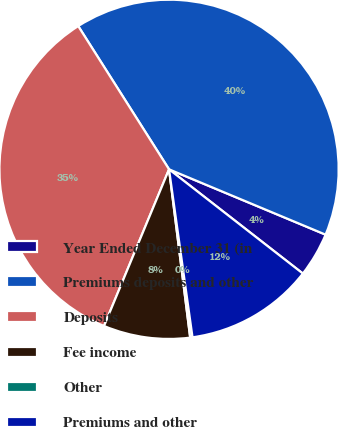Convert chart to OTSL. <chart><loc_0><loc_0><loc_500><loc_500><pie_chart><fcel>Year Ended December 31 (in<fcel>Premiums deposits and other<fcel>Deposits<fcel>Fee income<fcel>Other<fcel>Premiums and other<nl><fcel>4.24%<fcel>40.29%<fcel>34.75%<fcel>8.25%<fcel>0.22%<fcel>12.26%<nl></chart> 